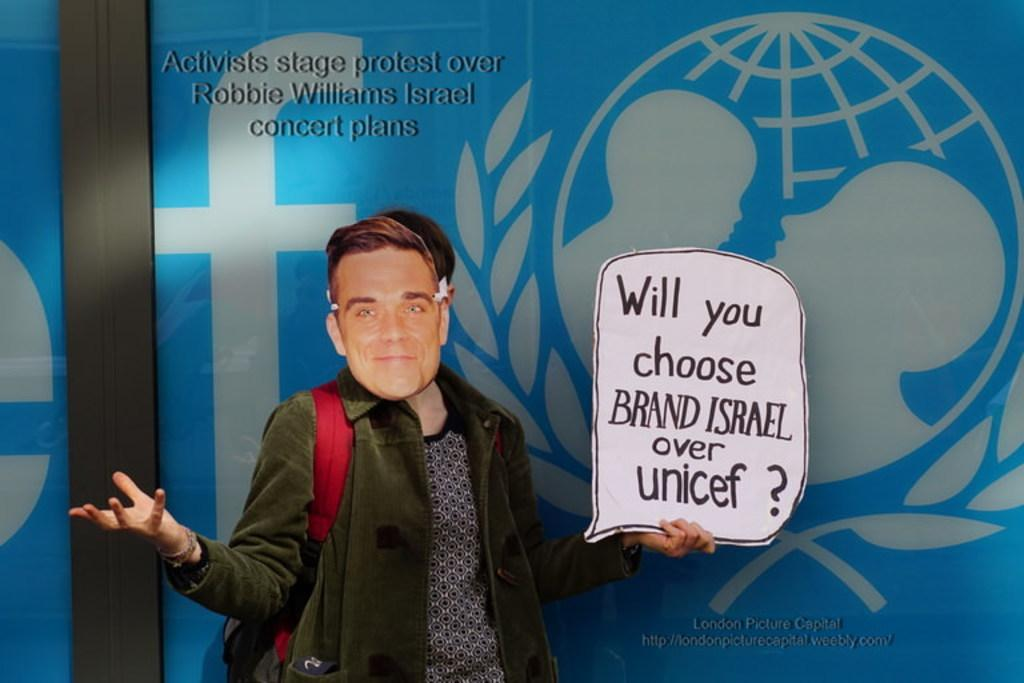Who is present in the image? There is a person in the image. What is the person wearing? The person is wearing a mask. What is the person holding in the image? The person is holding a board. What can be seen on the board? There is text on the board. What is visible in the background of the image? There is a banner in the background of the image. What type of toys can be seen on the person's desk in the image? There is no desk or toys present in the image. 